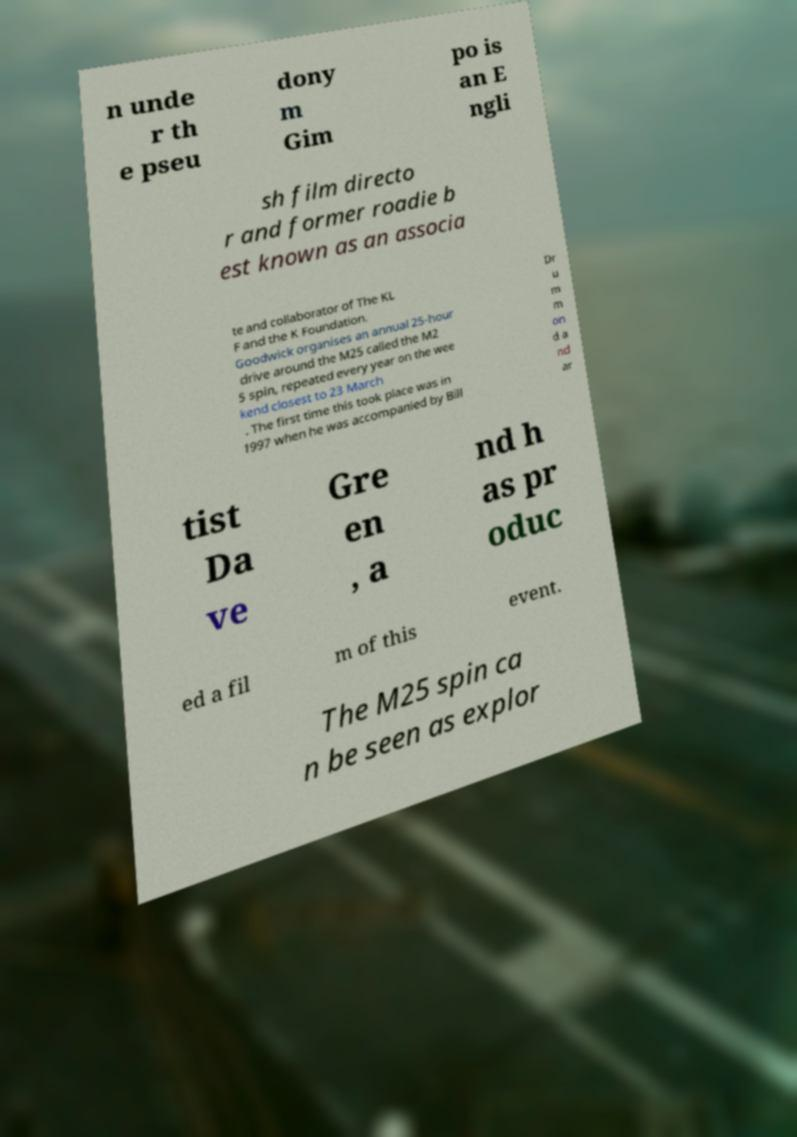What messages or text are displayed in this image? I need them in a readable, typed format. n unde r th e pseu dony m Gim po is an E ngli sh film directo r and former roadie b est known as an associa te and collaborator of The KL F and the K Foundation. Goodwick organises an annual 25-hour drive around the M25 called the M2 5 spin, repeated every year on the wee kend closest to 23 March . The first time this took place was in 1997 when he was accompanied by Bill Dr u m m on d a nd ar tist Da ve Gre en , a nd h as pr oduc ed a fil m of this event. The M25 spin ca n be seen as explor 